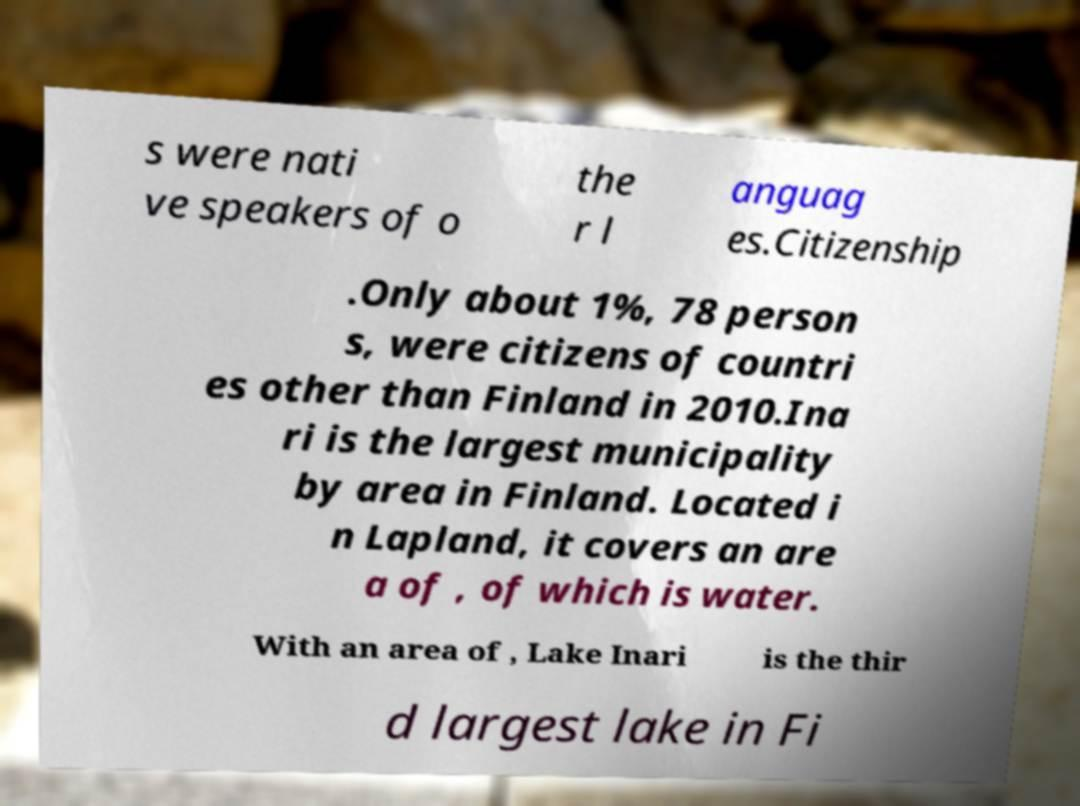Please read and relay the text visible in this image. What does it say? s were nati ve speakers of o the r l anguag es.Citizenship .Only about 1%, 78 person s, were citizens of countri es other than Finland in 2010.Ina ri is the largest municipality by area in Finland. Located i n Lapland, it covers an are a of , of which is water. With an area of , Lake Inari is the thir d largest lake in Fi 